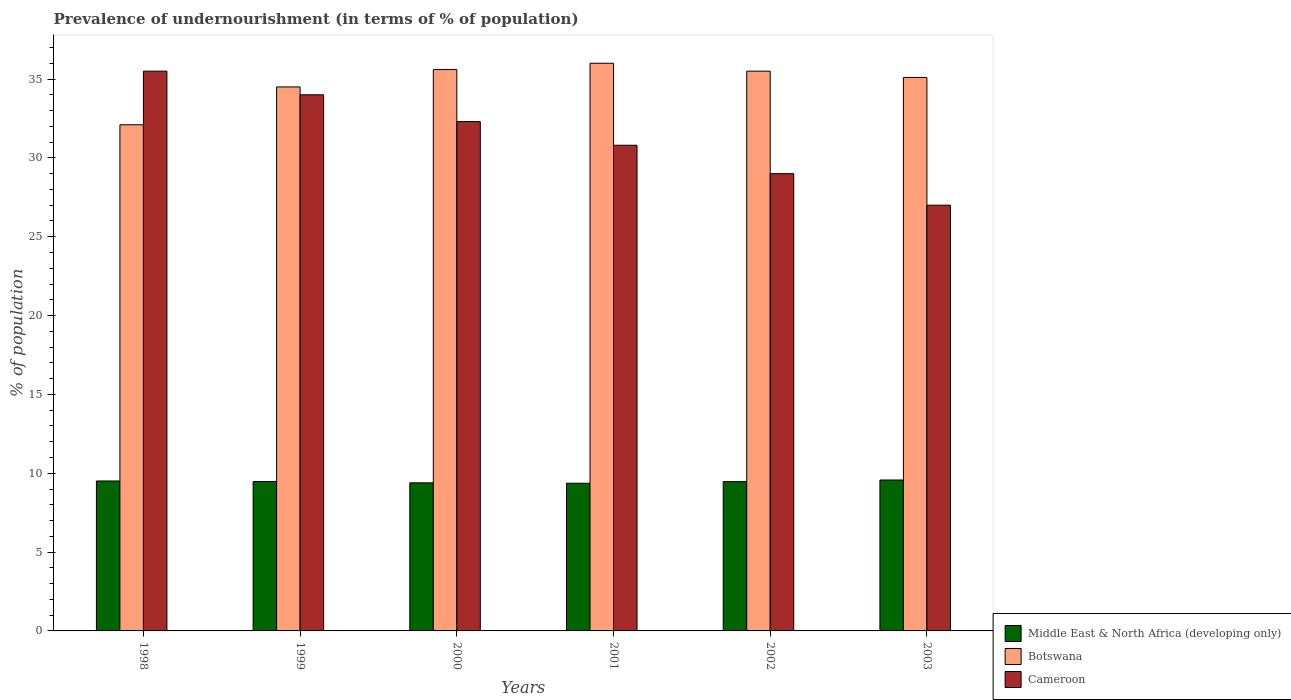Are the number of bars per tick equal to the number of legend labels?
Provide a short and direct response. Yes. Are the number of bars on each tick of the X-axis equal?
Your response must be concise. Yes. How many bars are there on the 2nd tick from the left?
Provide a succinct answer. 3. How many bars are there on the 5th tick from the right?
Provide a short and direct response. 3. What is the label of the 2nd group of bars from the left?
Offer a terse response. 1999. In how many cases, is the number of bars for a given year not equal to the number of legend labels?
Ensure brevity in your answer.  0. What is the percentage of undernourished population in Botswana in 1999?
Keep it short and to the point. 34.5. In which year was the percentage of undernourished population in Cameroon minimum?
Keep it short and to the point. 2003. What is the total percentage of undernourished population in Middle East & North Africa (developing only) in the graph?
Offer a terse response. 56.78. What is the difference between the percentage of undernourished population in Middle East & North Africa (developing only) in 2000 and the percentage of undernourished population in Botswana in 2002?
Make the answer very short. -26.11. What is the average percentage of undernourished population in Botswana per year?
Give a very brief answer. 34.8. In the year 2000, what is the difference between the percentage of undernourished population in Cameroon and percentage of undernourished population in Middle East & North Africa (developing only)?
Provide a short and direct response. 22.91. In how many years, is the percentage of undernourished population in Cameroon greater than 3 %?
Ensure brevity in your answer.  6. What is the ratio of the percentage of undernourished population in Botswana in 2000 to that in 2002?
Ensure brevity in your answer.  1. Is the difference between the percentage of undernourished population in Cameroon in 1998 and 1999 greater than the difference between the percentage of undernourished population in Middle East & North Africa (developing only) in 1998 and 1999?
Make the answer very short. Yes. What is the difference between the highest and the second highest percentage of undernourished population in Botswana?
Provide a short and direct response. 0.4. In how many years, is the percentage of undernourished population in Middle East & North Africa (developing only) greater than the average percentage of undernourished population in Middle East & North Africa (developing only) taken over all years?
Your answer should be compact. 4. Is the sum of the percentage of undernourished population in Middle East & North Africa (developing only) in 1998 and 1999 greater than the maximum percentage of undernourished population in Cameroon across all years?
Give a very brief answer. No. What does the 3rd bar from the left in 2001 represents?
Provide a short and direct response. Cameroon. What does the 2nd bar from the right in 1998 represents?
Your answer should be compact. Botswana. How many years are there in the graph?
Provide a succinct answer. 6. Are the values on the major ticks of Y-axis written in scientific E-notation?
Offer a terse response. No. Does the graph contain any zero values?
Your response must be concise. No. Does the graph contain grids?
Your answer should be very brief. No. How many legend labels are there?
Offer a very short reply. 3. What is the title of the graph?
Give a very brief answer. Prevalence of undernourishment (in terms of % of population). Does "United States" appear as one of the legend labels in the graph?
Your response must be concise. No. What is the label or title of the X-axis?
Offer a terse response. Years. What is the label or title of the Y-axis?
Make the answer very short. % of population. What is the % of population in Middle East & North Africa (developing only) in 1998?
Offer a very short reply. 9.51. What is the % of population of Botswana in 1998?
Make the answer very short. 32.1. What is the % of population in Cameroon in 1998?
Your response must be concise. 35.5. What is the % of population in Middle East & North Africa (developing only) in 1999?
Keep it short and to the point. 9.48. What is the % of population in Botswana in 1999?
Your answer should be compact. 34.5. What is the % of population of Cameroon in 1999?
Offer a terse response. 34. What is the % of population in Middle East & North Africa (developing only) in 2000?
Offer a terse response. 9.39. What is the % of population of Botswana in 2000?
Provide a succinct answer. 35.6. What is the % of population of Cameroon in 2000?
Give a very brief answer. 32.3. What is the % of population of Middle East & North Africa (developing only) in 2001?
Provide a succinct answer. 9.37. What is the % of population of Botswana in 2001?
Keep it short and to the point. 36. What is the % of population of Cameroon in 2001?
Make the answer very short. 30.8. What is the % of population of Middle East & North Africa (developing only) in 2002?
Give a very brief answer. 9.47. What is the % of population of Botswana in 2002?
Provide a short and direct response. 35.5. What is the % of population of Cameroon in 2002?
Offer a terse response. 29. What is the % of population in Middle East & North Africa (developing only) in 2003?
Give a very brief answer. 9.57. What is the % of population in Botswana in 2003?
Ensure brevity in your answer.  35.1. What is the % of population of Cameroon in 2003?
Make the answer very short. 27. Across all years, what is the maximum % of population in Middle East & North Africa (developing only)?
Provide a succinct answer. 9.57. Across all years, what is the maximum % of population in Botswana?
Ensure brevity in your answer.  36. Across all years, what is the maximum % of population of Cameroon?
Offer a very short reply. 35.5. Across all years, what is the minimum % of population in Middle East & North Africa (developing only)?
Provide a short and direct response. 9.37. Across all years, what is the minimum % of population of Botswana?
Offer a terse response. 32.1. What is the total % of population of Middle East & North Africa (developing only) in the graph?
Your answer should be very brief. 56.78. What is the total % of population in Botswana in the graph?
Your answer should be compact. 208.8. What is the total % of population in Cameroon in the graph?
Ensure brevity in your answer.  188.6. What is the difference between the % of population in Middle East & North Africa (developing only) in 1998 and that in 1999?
Keep it short and to the point. 0.03. What is the difference between the % of population in Middle East & North Africa (developing only) in 1998 and that in 2000?
Ensure brevity in your answer.  0.12. What is the difference between the % of population in Middle East & North Africa (developing only) in 1998 and that in 2001?
Provide a succinct answer. 0.14. What is the difference between the % of population in Cameroon in 1998 and that in 2001?
Give a very brief answer. 4.7. What is the difference between the % of population in Middle East & North Africa (developing only) in 1998 and that in 2002?
Your answer should be compact. 0.04. What is the difference between the % of population of Botswana in 1998 and that in 2002?
Your answer should be very brief. -3.4. What is the difference between the % of population in Middle East & North Africa (developing only) in 1998 and that in 2003?
Give a very brief answer. -0.06. What is the difference between the % of population of Middle East & North Africa (developing only) in 1999 and that in 2000?
Your answer should be very brief. 0.08. What is the difference between the % of population of Middle East & North Africa (developing only) in 1999 and that in 2001?
Offer a terse response. 0.11. What is the difference between the % of population of Cameroon in 1999 and that in 2001?
Your answer should be very brief. 3.2. What is the difference between the % of population in Middle East & North Africa (developing only) in 1999 and that in 2002?
Your answer should be very brief. 0.01. What is the difference between the % of population of Botswana in 1999 and that in 2002?
Give a very brief answer. -1. What is the difference between the % of population in Cameroon in 1999 and that in 2002?
Your answer should be compact. 5. What is the difference between the % of population of Middle East & North Africa (developing only) in 1999 and that in 2003?
Your answer should be compact. -0.1. What is the difference between the % of population of Botswana in 1999 and that in 2003?
Offer a very short reply. -0.6. What is the difference between the % of population in Cameroon in 1999 and that in 2003?
Offer a terse response. 7. What is the difference between the % of population in Middle East & North Africa (developing only) in 2000 and that in 2001?
Provide a short and direct response. 0.03. What is the difference between the % of population in Botswana in 2000 and that in 2001?
Offer a very short reply. -0.4. What is the difference between the % of population of Middle East & North Africa (developing only) in 2000 and that in 2002?
Your answer should be compact. -0.08. What is the difference between the % of population in Middle East & North Africa (developing only) in 2000 and that in 2003?
Provide a succinct answer. -0.18. What is the difference between the % of population in Botswana in 2000 and that in 2003?
Offer a very short reply. 0.5. What is the difference between the % of population of Middle East & North Africa (developing only) in 2001 and that in 2002?
Your answer should be compact. -0.1. What is the difference between the % of population in Botswana in 2001 and that in 2002?
Your answer should be very brief. 0.5. What is the difference between the % of population of Cameroon in 2001 and that in 2002?
Offer a very short reply. 1.8. What is the difference between the % of population in Middle East & North Africa (developing only) in 2001 and that in 2003?
Provide a succinct answer. -0.2. What is the difference between the % of population of Botswana in 2001 and that in 2003?
Give a very brief answer. 0.9. What is the difference between the % of population in Middle East & North Africa (developing only) in 2002 and that in 2003?
Provide a succinct answer. -0.1. What is the difference between the % of population of Middle East & North Africa (developing only) in 1998 and the % of population of Botswana in 1999?
Make the answer very short. -24.99. What is the difference between the % of population in Middle East & North Africa (developing only) in 1998 and the % of population in Cameroon in 1999?
Your answer should be compact. -24.49. What is the difference between the % of population of Botswana in 1998 and the % of population of Cameroon in 1999?
Ensure brevity in your answer.  -1.9. What is the difference between the % of population in Middle East & North Africa (developing only) in 1998 and the % of population in Botswana in 2000?
Offer a very short reply. -26.09. What is the difference between the % of population in Middle East & North Africa (developing only) in 1998 and the % of population in Cameroon in 2000?
Your answer should be very brief. -22.79. What is the difference between the % of population in Middle East & North Africa (developing only) in 1998 and the % of population in Botswana in 2001?
Offer a terse response. -26.49. What is the difference between the % of population in Middle East & North Africa (developing only) in 1998 and the % of population in Cameroon in 2001?
Provide a succinct answer. -21.29. What is the difference between the % of population of Middle East & North Africa (developing only) in 1998 and the % of population of Botswana in 2002?
Offer a terse response. -25.99. What is the difference between the % of population of Middle East & North Africa (developing only) in 1998 and the % of population of Cameroon in 2002?
Offer a very short reply. -19.49. What is the difference between the % of population of Middle East & North Africa (developing only) in 1998 and the % of population of Botswana in 2003?
Keep it short and to the point. -25.59. What is the difference between the % of population in Middle East & North Africa (developing only) in 1998 and the % of population in Cameroon in 2003?
Your response must be concise. -17.49. What is the difference between the % of population in Botswana in 1998 and the % of population in Cameroon in 2003?
Your answer should be very brief. 5.1. What is the difference between the % of population of Middle East & North Africa (developing only) in 1999 and the % of population of Botswana in 2000?
Ensure brevity in your answer.  -26.12. What is the difference between the % of population in Middle East & North Africa (developing only) in 1999 and the % of population in Cameroon in 2000?
Give a very brief answer. -22.82. What is the difference between the % of population of Botswana in 1999 and the % of population of Cameroon in 2000?
Make the answer very short. 2.2. What is the difference between the % of population in Middle East & North Africa (developing only) in 1999 and the % of population in Botswana in 2001?
Offer a terse response. -26.52. What is the difference between the % of population in Middle East & North Africa (developing only) in 1999 and the % of population in Cameroon in 2001?
Keep it short and to the point. -21.32. What is the difference between the % of population of Botswana in 1999 and the % of population of Cameroon in 2001?
Make the answer very short. 3.7. What is the difference between the % of population of Middle East & North Africa (developing only) in 1999 and the % of population of Botswana in 2002?
Ensure brevity in your answer.  -26.02. What is the difference between the % of population in Middle East & North Africa (developing only) in 1999 and the % of population in Cameroon in 2002?
Ensure brevity in your answer.  -19.52. What is the difference between the % of population in Middle East & North Africa (developing only) in 1999 and the % of population in Botswana in 2003?
Provide a short and direct response. -25.62. What is the difference between the % of population in Middle East & North Africa (developing only) in 1999 and the % of population in Cameroon in 2003?
Your answer should be very brief. -17.52. What is the difference between the % of population of Middle East & North Africa (developing only) in 2000 and the % of population of Botswana in 2001?
Your answer should be very brief. -26.61. What is the difference between the % of population in Middle East & North Africa (developing only) in 2000 and the % of population in Cameroon in 2001?
Ensure brevity in your answer.  -21.41. What is the difference between the % of population of Middle East & North Africa (developing only) in 2000 and the % of population of Botswana in 2002?
Provide a short and direct response. -26.11. What is the difference between the % of population of Middle East & North Africa (developing only) in 2000 and the % of population of Cameroon in 2002?
Offer a very short reply. -19.61. What is the difference between the % of population in Middle East & North Africa (developing only) in 2000 and the % of population in Botswana in 2003?
Make the answer very short. -25.71. What is the difference between the % of population in Middle East & North Africa (developing only) in 2000 and the % of population in Cameroon in 2003?
Ensure brevity in your answer.  -17.61. What is the difference between the % of population of Botswana in 2000 and the % of population of Cameroon in 2003?
Ensure brevity in your answer.  8.6. What is the difference between the % of population in Middle East & North Africa (developing only) in 2001 and the % of population in Botswana in 2002?
Provide a short and direct response. -26.13. What is the difference between the % of population in Middle East & North Africa (developing only) in 2001 and the % of population in Cameroon in 2002?
Provide a short and direct response. -19.63. What is the difference between the % of population of Botswana in 2001 and the % of population of Cameroon in 2002?
Make the answer very short. 7. What is the difference between the % of population of Middle East & North Africa (developing only) in 2001 and the % of population of Botswana in 2003?
Your response must be concise. -25.73. What is the difference between the % of population in Middle East & North Africa (developing only) in 2001 and the % of population in Cameroon in 2003?
Keep it short and to the point. -17.63. What is the difference between the % of population in Botswana in 2001 and the % of population in Cameroon in 2003?
Ensure brevity in your answer.  9. What is the difference between the % of population of Middle East & North Africa (developing only) in 2002 and the % of population of Botswana in 2003?
Provide a succinct answer. -25.63. What is the difference between the % of population in Middle East & North Africa (developing only) in 2002 and the % of population in Cameroon in 2003?
Your response must be concise. -17.53. What is the average % of population in Middle East & North Africa (developing only) per year?
Ensure brevity in your answer.  9.46. What is the average % of population of Botswana per year?
Offer a very short reply. 34.8. What is the average % of population of Cameroon per year?
Your answer should be very brief. 31.43. In the year 1998, what is the difference between the % of population of Middle East & North Africa (developing only) and % of population of Botswana?
Your answer should be compact. -22.59. In the year 1998, what is the difference between the % of population of Middle East & North Africa (developing only) and % of population of Cameroon?
Give a very brief answer. -25.99. In the year 1999, what is the difference between the % of population in Middle East & North Africa (developing only) and % of population in Botswana?
Your answer should be very brief. -25.02. In the year 1999, what is the difference between the % of population of Middle East & North Africa (developing only) and % of population of Cameroon?
Provide a short and direct response. -24.52. In the year 1999, what is the difference between the % of population in Botswana and % of population in Cameroon?
Provide a succinct answer. 0.5. In the year 2000, what is the difference between the % of population in Middle East & North Africa (developing only) and % of population in Botswana?
Offer a very short reply. -26.21. In the year 2000, what is the difference between the % of population in Middle East & North Africa (developing only) and % of population in Cameroon?
Give a very brief answer. -22.91. In the year 2001, what is the difference between the % of population in Middle East & North Africa (developing only) and % of population in Botswana?
Your response must be concise. -26.63. In the year 2001, what is the difference between the % of population in Middle East & North Africa (developing only) and % of population in Cameroon?
Offer a very short reply. -21.43. In the year 2001, what is the difference between the % of population in Botswana and % of population in Cameroon?
Keep it short and to the point. 5.2. In the year 2002, what is the difference between the % of population in Middle East & North Africa (developing only) and % of population in Botswana?
Your answer should be compact. -26.03. In the year 2002, what is the difference between the % of population in Middle East & North Africa (developing only) and % of population in Cameroon?
Ensure brevity in your answer.  -19.53. In the year 2003, what is the difference between the % of population of Middle East & North Africa (developing only) and % of population of Botswana?
Your response must be concise. -25.53. In the year 2003, what is the difference between the % of population in Middle East & North Africa (developing only) and % of population in Cameroon?
Offer a terse response. -17.43. In the year 2003, what is the difference between the % of population in Botswana and % of population in Cameroon?
Your answer should be compact. 8.1. What is the ratio of the % of population in Middle East & North Africa (developing only) in 1998 to that in 1999?
Ensure brevity in your answer.  1. What is the ratio of the % of population of Botswana in 1998 to that in 1999?
Ensure brevity in your answer.  0.93. What is the ratio of the % of population of Cameroon in 1998 to that in 1999?
Offer a terse response. 1.04. What is the ratio of the % of population of Middle East & North Africa (developing only) in 1998 to that in 2000?
Provide a succinct answer. 1.01. What is the ratio of the % of population of Botswana in 1998 to that in 2000?
Give a very brief answer. 0.9. What is the ratio of the % of population of Cameroon in 1998 to that in 2000?
Keep it short and to the point. 1.1. What is the ratio of the % of population of Middle East & North Africa (developing only) in 1998 to that in 2001?
Provide a short and direct response. 1.02. What is the ratio of the % of population of Botswana in 1998 to that in 2001?
Provide a short and direct response. 0.89. What is the ratio of the % of population of Cameroon in 1998 to that in 2001?
Give a very brief answer. 1.15. What is the ratio of the % of population in Middle East & North Africa (developing only) in 1998 to that in 2002?
Offer a terse response. 1. What is the ratio of the % of population in Botswana in 1998 to that in 2002?
Ensure brevity in your answer.  0.9. What is the ratio of the % of population in Cameroon in 1998 to that in 2002?
Give a very brief answer. 1.22. What is the ratio of the % of population in Middle East & North Africa (developing only) in 1998 to that in 2003?
Provide a succinct answer. 0.99. What is the ratio of the % of population of Botswana in 1998 to that in 2003?
Offer a terse response. 0.91. What is the ratio of the % of population of Cameroon in 1998 to that in 2003?
Offer a terse response. 1.31. What is the ratio of the % of population in Middle East & North Africa (developing only) in 1999 to that in 2000?
Your answer should be very brief. 1.01. What is the ratio of the % of population of Botswana in 1999 to that in 2000?
Provide a succinct answer. 0.97. What is the ratio of the % of population of Cameroon in 1999 to that in 2000?
Give a very brief answer. 1.05. What is the ratio of the % of population in Middle East & North Africa (developing only) in 1999 to that in 2001?
Your response must be concise. 1.01. What is the ratio of the % of population of Cameroon in 1999 to that in 2001?
Give a very brief answer. 1.1. What is the ratio of the % of population in Botswana in 1999 to that in 2002?
Your response must be concise. 0.97. What is the ratio of the % of population of Cameroon in 1999 to that in 2002?
Your answer should be very brief. 1.17. What is the ratio of the % of population of Middle East & North Africa (developing only) in 1999 to that in 2003?
Offer a terse response. 0.99. What is the ratio of the % of population in Botswana in 1999 to that in 2003?
Provide a succinct answer. 0.98. What is the ratio of the % of population of Cameroon in 1999 to that in 2003?
Your answer should be very brief. 1.26. What is the ratio of the % of population of Middle East & North Africa (developing only) in 2000 to that in 2001?
Give a very brief answer. 1. What is the ratio of the % of population in Botswana in 2000 to that in 2001?
Your answer should be very brief. 0.99. What is the ratio of the % of population of Cameroon in 2000 to that in 2001?
Give a very brief answer. 1.05. What is the ratio of the % of population in Middle East & North Africa (developing only) in 2000 to that in 2002?
Keep it short and to the point. 0.99. What is the ratio of the % of population in Botswana in 2000 to that in 2002?
Provide a short and direct response. 1. What is the ratio of the % of population in Cameroon in 2000 to that in 2002?
Provide a short and direct response. 1.11. What is the ratio of the % of population in Middle East & North Africa (developing only) in 2000 to that in 2003?
Offer a terse response. 0.98. What is the ratio of the % of population in Botswana in 2000 to that in 2003?
Provide a short and direct response. 1.01. What is the ratio of the % of population in Cameroon in 2000 to that in 2003?
Offer a terse response. 1.2. What is the ratio of the % of population of Middle East & North Africa (developing only) in 2001 to that in 2002?
Your answer should be very brief. 0.99. What is the ratio of the % of population of Botswana in 2001 to that in 2002?
Give a very brief answer. 1.01. What is the ratio of the % of population of Cameroon in 2001 to that in 2002?
Your answer should be very brief. 1.06. What is the ratio of the % of population of Middle East & North Africa (developing only) in 2001 to that in 2003?
Keep it short and to the point. 0.98. What is the ratio of the % of population in Botswana in 2001 to that in 2003?
Give a very brief answer. 1.03. What is the ratio of the % of population in Cameroon in 2001 to that in 2003?
Your answer should be compact. 1.14. What is the ratio of the % of population of Botswana in 2002 to that in 2003?
Ensure brevity in your answer.  1.01. What is the ratio of the % of population in Cameroon in 2002 to that in 2003?
Your answer should be compact. 1.07. What is the difference between the highest and the second highest % of population in Middle East & North Africa (developing only)?
Provide a succinct answer. 0.06. What is the difference between the highest and the second highest % of population of Botswana?
Make the answer very short. 0.4. What is the difference between the highest and the lowest % of population of Middle East & North Africa (developing only)?
Provide a succinct answer. 0.2. What is the difference between the highest and the lowest % of population of Botswana?
Offer a very short reply. 3.9. What is the difference between the highest and the lowest % of population of Cameroon?
Make the answer very short. 8.5. 